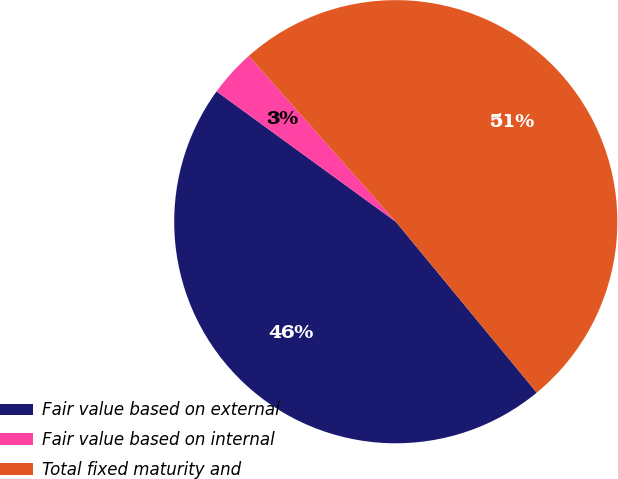<chart> <loc_0><loc_0><loc_500><loc_500><pie_chart><fcel>Fair value based on external<fcel>Fair value based on internal<fcel>Total fixed maturity and<nl><fcel>45.98%<fcel>3.45%<fcel>50.57%<nl></chart> 